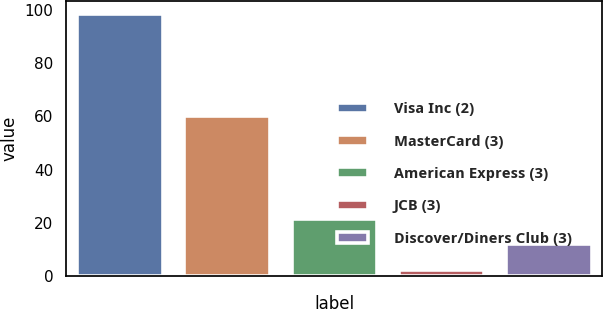Convert chart. <chart><loc_0><loc_0><loc_500><loc_500><bar_chart><fcel>Visa Inc (2)<fcel>MasterCard (3)<fcel>American Express (3)<fcel>JCB (3)<fcel>Discover/Diners Club (3)<nl><fcel>98.4<fcel>60.1<fcel>21.6<fcel>2.4<fcel>12<nl></chart> 